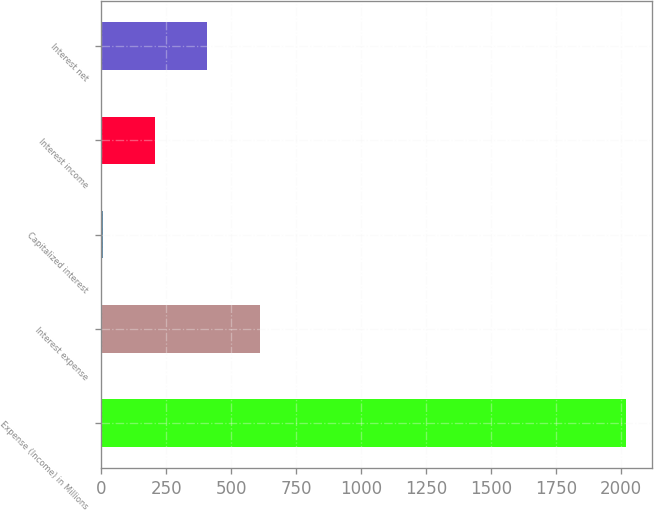Convert chart. <chart><loc_0><loc_0><loc_500><loc_500><bar_chart><fcel>Expense (Income) in Millions<fcel>Interest expense<fcel>Capitalized interest<fcel>Interest income<fcel>Interest net<nl><fcel>2017<fcel>608.32<fcel>4.6<fcel>205.84<fcel>407.08<nl></chart> 